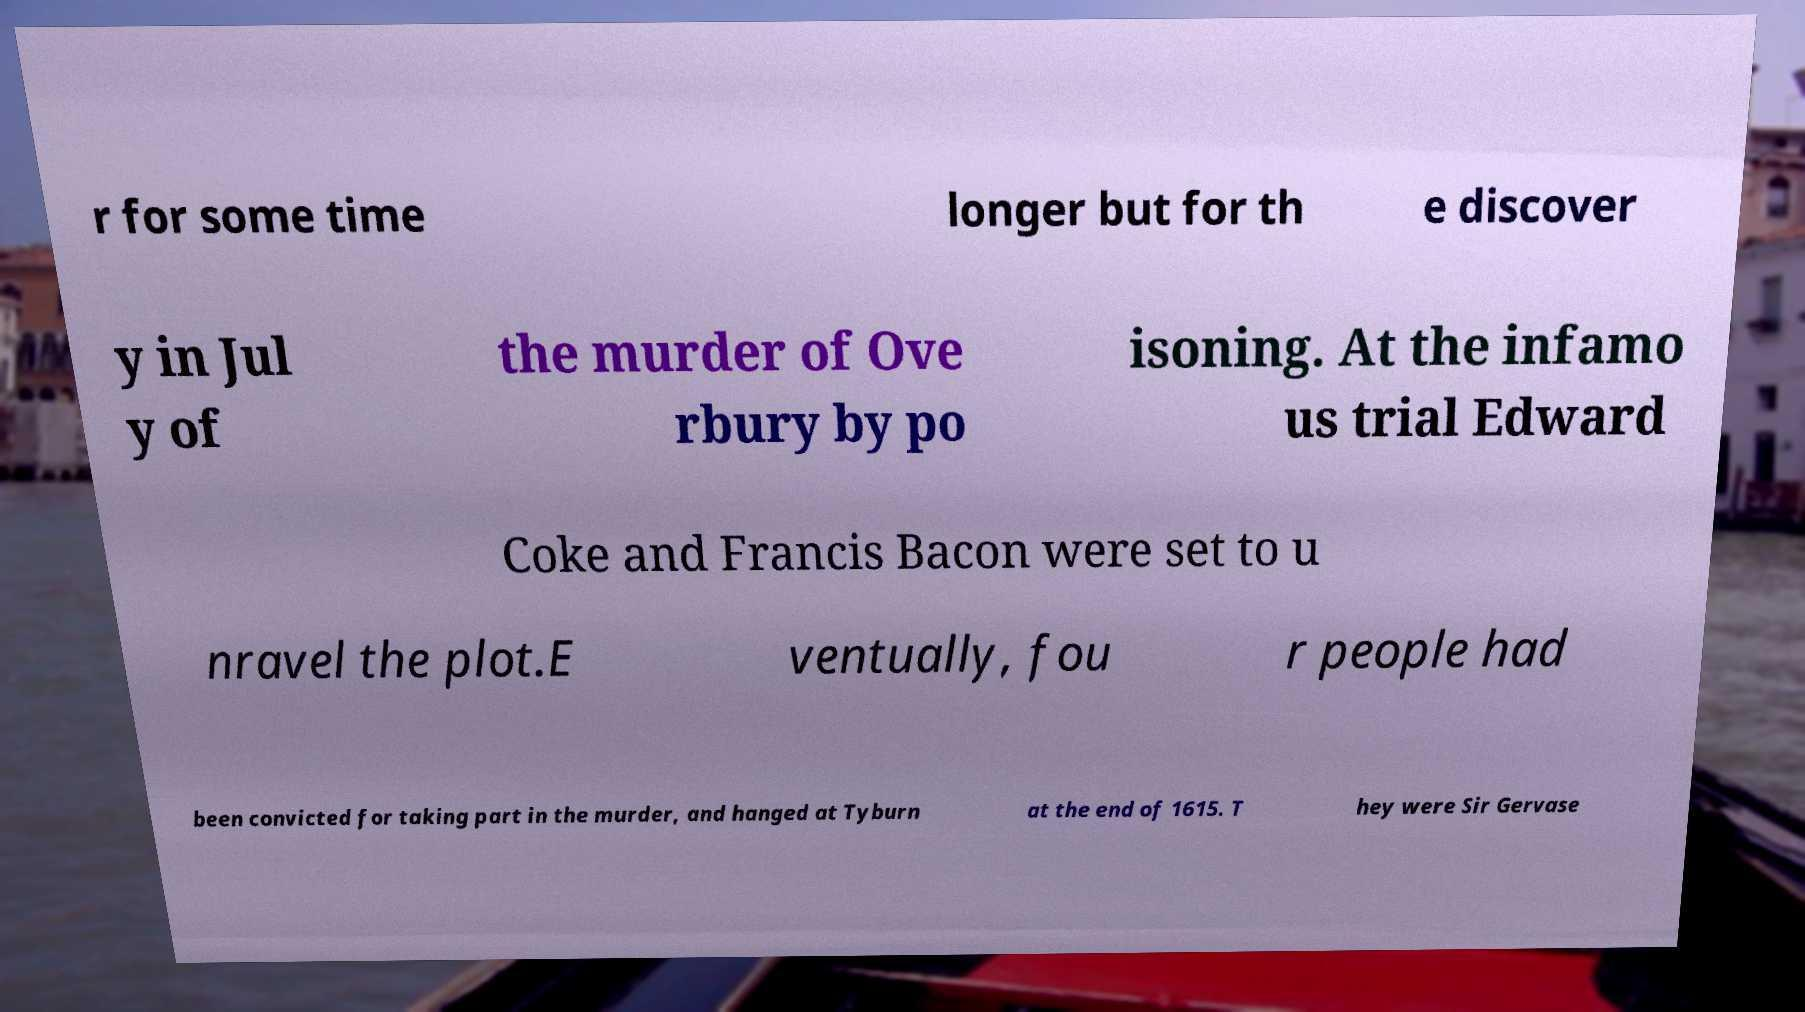Please read and relay the text visible in this image. What does it say? r for some time longer but for th e discover y in Jul y of the murder of Ove rbury by po isoning. At the infamo us trial Edward Coke and Francis Bacon were set to u nravel the plot.E ventually, fou r people had been convicted for taking part in the murder, and hanged at Tyburn at the end of 1615. T hey were Sir Gervase 